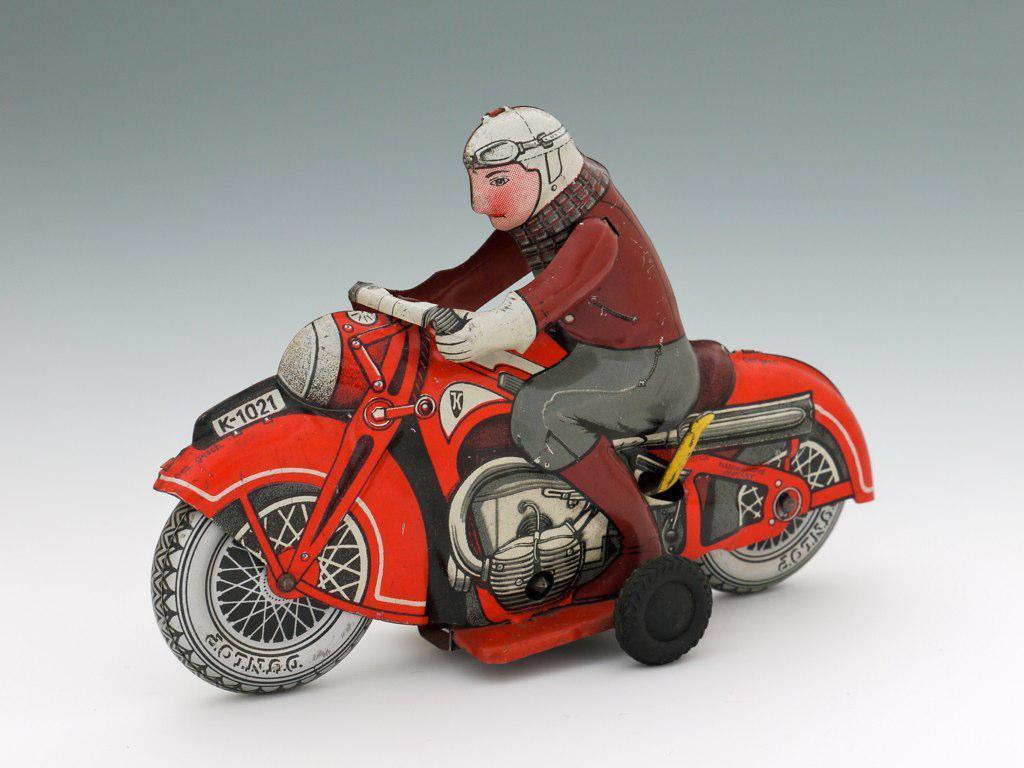Describe this image in one or two sentences. In the image we can see an animated picture of a person, wearing clothes, gloves, helmet, goggles and shoes, and the person is sitting on the bike. 